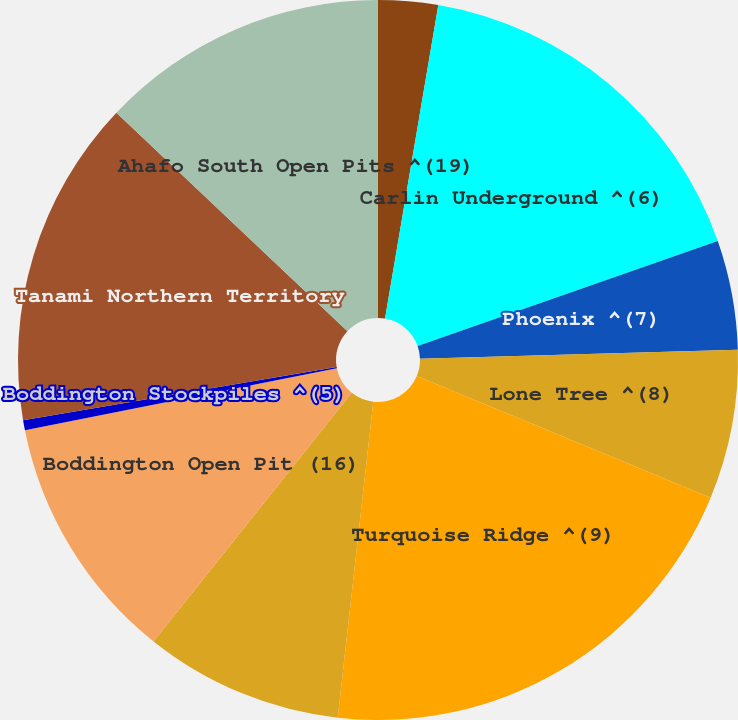<chart> <loc_0><loc_0><loc_500><loc_500><pie_chart><fcel>Carlin Open Pits (4)<fcel>Carlin Underground ^(6)<fcel>Phoenix ^(7)<fcel>Lone Tree ^(8)<fcel>Turquoise Ridge ^(9)<fcel>Yanacocha Open Pits ^(14)<fcel>Boddington Open Pit (16)<fcel>Boddington Stockpiles ^(5)<fcel>Tanami Northern Territory<fcel>Ahafo South Open Pits ^(19)<nl><fcel>2.68%<fcel>16.96%<fcel>4.91%<fcel>6.7%<fcel>20.54%<fcel>8.93%<fcel>11.16%<fcel>0.45%<fcel>14.73%<fcel>12.95%<nl></chart> 